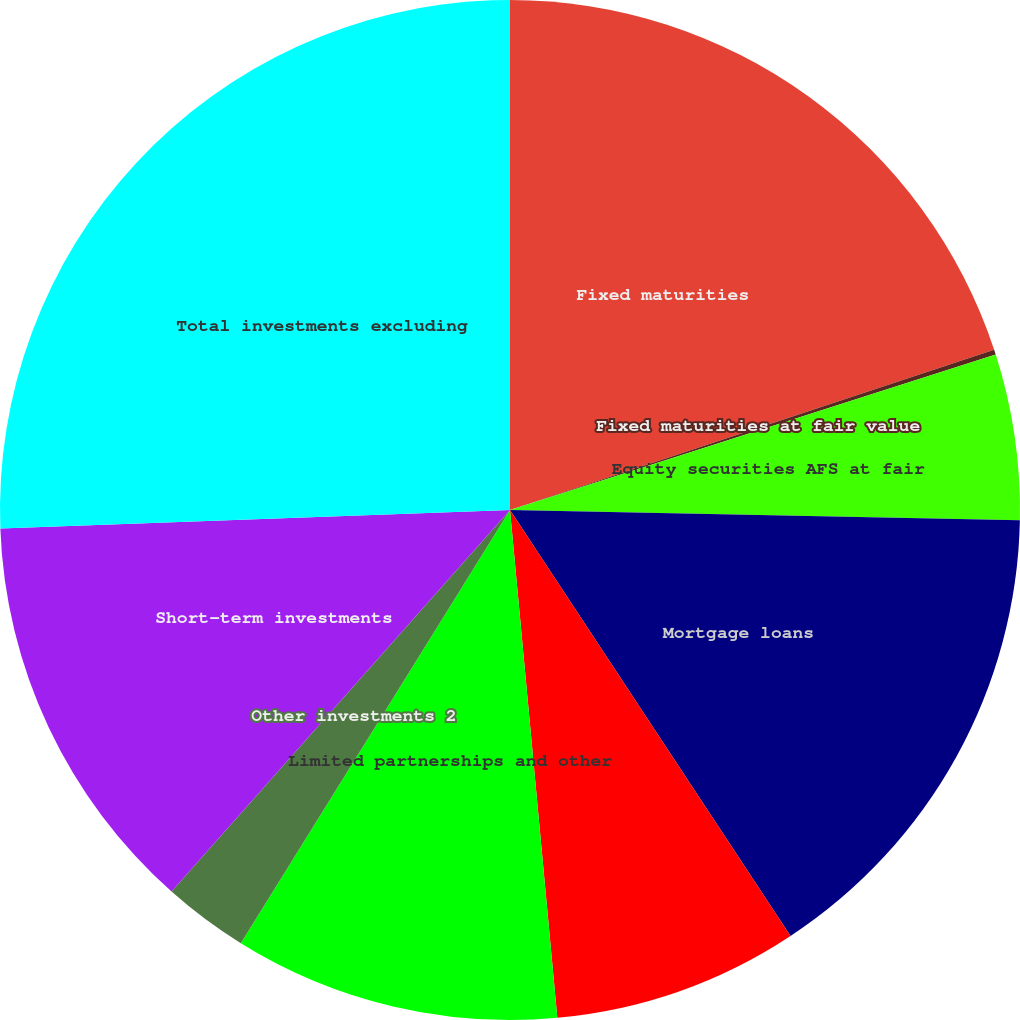Convert chart to OTSL. <chart><loc_0><loc_0><loc_500><loc_500><pie_chart><fcel>Fixed maturities<fcel>Fixed maturities at fair value<fcel>Equity securities AFS at fair<fcel>Mortgage loans<fcel>Policy loans at outstanding<fcel>Limited partnerships and other<fcel>Other investments 2<fcel>Short-term investments<fcel>Total investments excluding<nl><fcel>19.91%<fcel>0.16%<fcel>5.25%<fcel>15.41%<fcel>7.79%<fcel>10.33%<fcel>2.7%<fcel>12.87%<fcel>25.58%<nl></chart> 